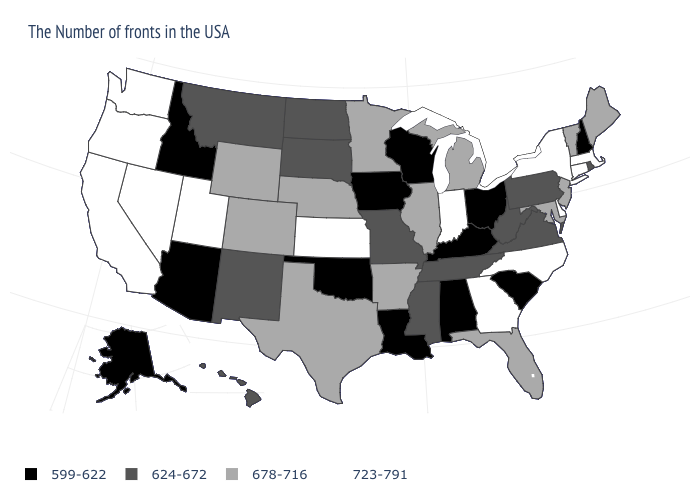Name the states that have a value in the range 624-672?
Keep it brief. Rhode Island, Pennsylvania, Virginia, West Virginia, Tennessee, Mississippi, Missouri, South Dakota, North Dakota, New Mexico, Montana, Hawaii. What is the value of South Carolina?
Write a very short answer. 599-622. Which states hav the highest value in the MidWest?
Answer briefly. Indiana, Kansas. Does Missouri have the same value as Tennessee?
Keep it brief. Yes. Which states have the lowest value in the USA?
Short answer required. New Hampshire, South Carolina, Ohio, Kentucky, Alabama, Wisconsin, Louisiana, Iowa, Oklahoma, Arizona, Idaho, Alaska. Does Mississippi have the highest value in the South?
Give a very brief answer. No. What is the highest value in states that border Washington?
Short answer required. 723-791. Among the states that border Ohio , does Kentucky have the lowest value?
Be succinct. Yes. Does New York have the highest value in the USA?
Be succinct. Yes. Does the map have missing data?
Short answer required. No. Which states have the lowest value in the West?
Give a very brief answer. Arizona, Idaho, Alaska. What is the value of North Dakota?
Answer briefly. 624-672. Which states hav the highest value in the West?
Answer briefly. Utah, Nevada, California, Washington, Oregon. Which states have the lowest value in the USA?
Give a very brief answer. New Hampshire, South Carolina, Ohio, Kentucky, Alabama, Wisconsin, Louisiana, Iowa, Oklahoma, Arizona, Idaho, Alaska. What is the value of Utah?
Short answer required. 723-791. 